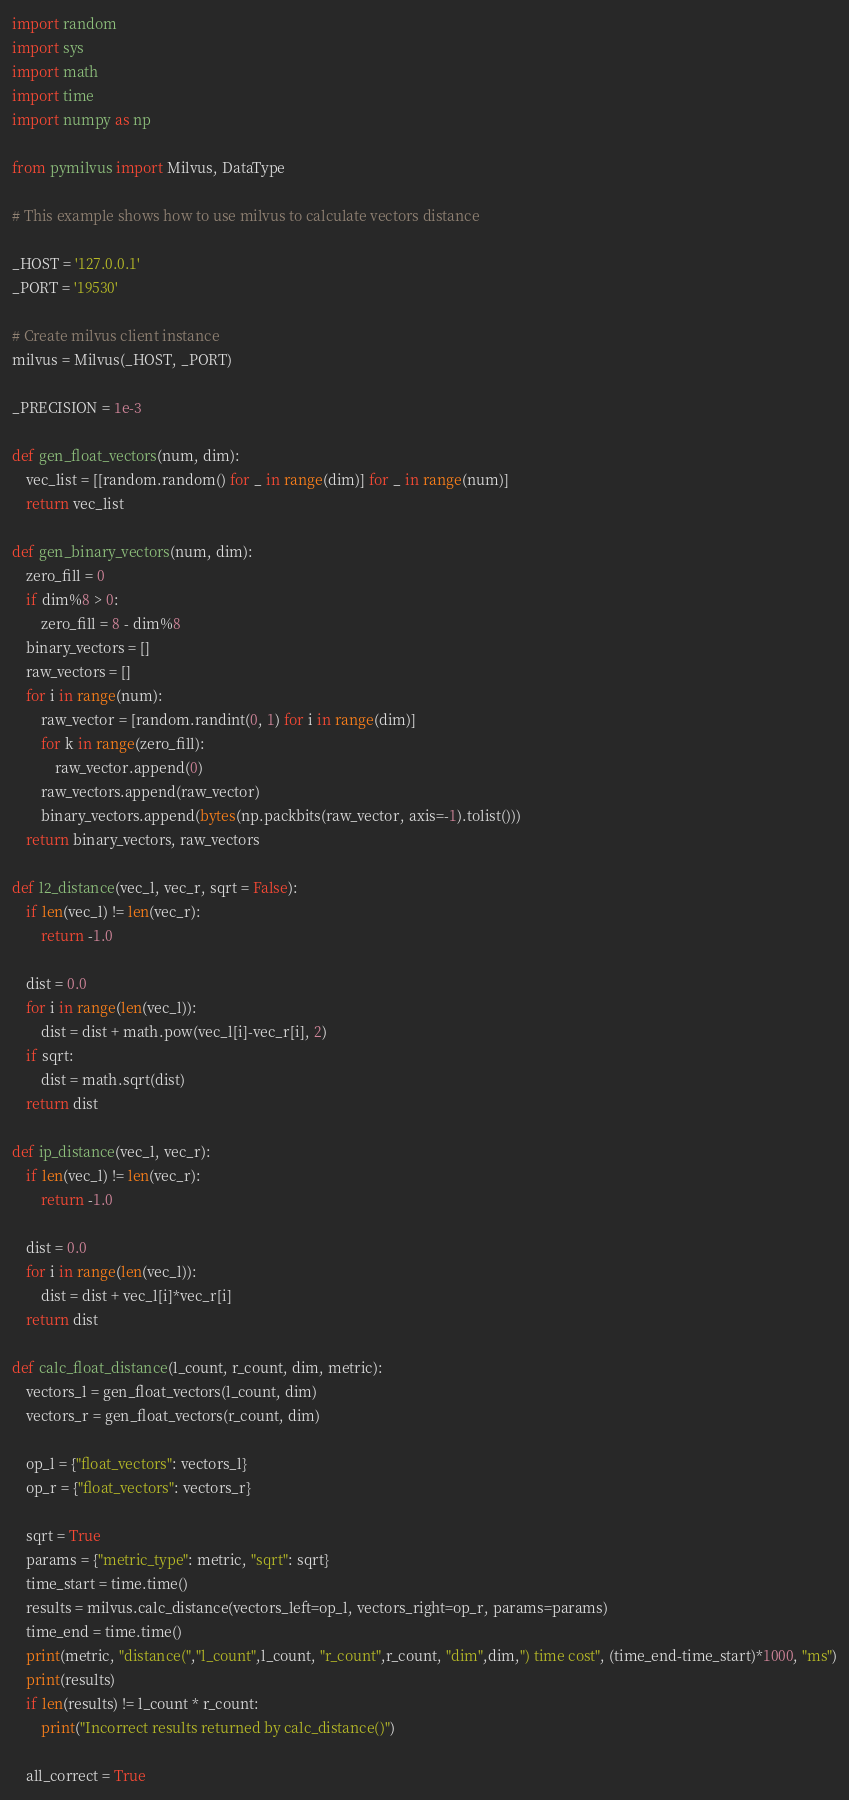Convert code to text. <code><loc_0><loc_0><loc_500><loc_500><_Python_>import random
import sys
import math
import time
import numpy as np

from pymilvus import Milvus, DataType

# This example shows how to use milvus to calculate vectors distance

_HOST = '127.0.0.1'
_PORT = '19530'

# Create milvus client instance
milvus = Milvus(_HOST, _PORT)

_PRECISION = 1e-3

def gen_float_vectors(num, dim):
    vec_list = [[random.random() for _ in range(dim)] for _ in range(num)]
    return vec_list

def gen_binary_vectors(num, dim):
    zero_fill = 0
    if dim%8 > 0:
        zero_fill = 8 - dim%8
    binary_vectors = []
    raw_vectors = []
    for i in range(num):
        raw_vector = [random.randint(0, 1) for i in range(dim)]
        for k in range(zero_fill):
            raw_vector.append(0)
        raw_vectors.append(raw_vector)
        binary_vectors.append(bytes(np.packbits(raw_vector, axis=-1).tolist()))
    return binary_vectors, raw_vectors

def l2_distance(vec_l, vec_r, sqrt = False):
    if len(vec_l) != len(vec_r):
        return -1.0

    dist = 0.0
    for i in range(len(vec_l)):
        dist = dist + math.pow(vec_l[i]-vec_r[i], 2)
    if sqrt:
        dist = math.sqrt(dist)
    return dist

def ip_distance(vec_l, vec_r):
    if len(vec_l) != len(vec_r):
        return -1.0

    dist = 0.0
    for i in range(len(vec_l)):
        dist = dist + vec_l[i]*vec_r[i]
    return dist

def calc_float_distance(l_count, r_count, dim, metric):
    vectors_l = gen_float_vectors(l_count, dim)
    vectors_r = gen_float_vectors(r_count, dim)

    op_l = {"float_vectors": vectors_l}
    op_r = {"float_vectors": vectors_r}

    sqrt = True
    params = {"metric_type": metric, "sqrt": sqrt}
    time_start = time.time()
    results = milvus.calc_distance(vectors_left=op_l, vectors_right=op_r, params=params)
    time_end = time.time()
    print(metric, "distance(","l_count",l_count, "r_count",r_count, "dim",dim,") time cost", (time_end-time_start)*1000, "ms")
    print(results)
    if len(results) != l_count * r_count:
        print("Incorrect results returned by calc_distance()")

    all_correct = True</code> 